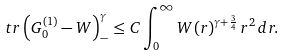<formula> <loc_0><loc_0><loc_500><loc_500>\ t r \left ( G _ { 0 } ^ { ( 1 ) } - W \right ) _ { - } ^ { \gamma } \leq C \int _ { 0 } ^ { \infty } W ( r ) ^ { \gamma + \frac { 3 } { 4 } } \, r ^ { 2 } \, d r .</formula> 